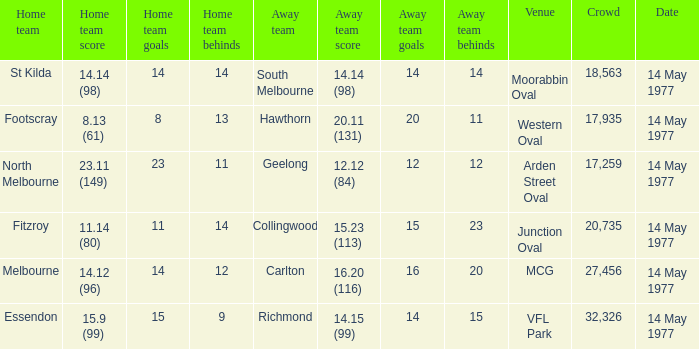Name the away team for essendon Richmond. Could you parse the entire table as a dict? {'header': ['Home team', 'Home team score', 'Home team goals', 'Home team behinds', 'Away team', 'Away team score', 'Away team goals', 'Away team behinds', 'Venue', 'Crowd', 'Date'], 'rows': [['St Kilda', '14.14 (98)', '14', '14', 'South Melbourne', '14.14 (98)', '14', '14', 'Moorabbin Oval', '18,563', '14 May 1977'], ['Footscray', '8.13 (61)', '8', '13', 'Hawthorn', '20.11 (131)', '20', '11', 'Western Oval', '17,935', '14 May 1977'], ['North Melbourne', '23.11 (149)', '23', '11', 'Geelong', '12.12 (84)', '12', '12', 'Arden Street Oval', '17,259', '14 May 1977'], ['Fitzroy', '11.14 (80)', '11', '14', 'Collingwood', '15.23 (113)', '15', '23', 'Junction Oval', '20,735', '14 May 1977'], ['Melbourne', '14.12 (96)', '14', '12', 'Carlton', '16.20 (116)', '16', '20', 'MCG', '27,456', '14 May 1977'], ['Essendon', '15.9 (99)', '15', '9', 'Richmond', '14.15 (99)', '14', '15', 'VFL Park', '32,326', '14 May 1977']]} 